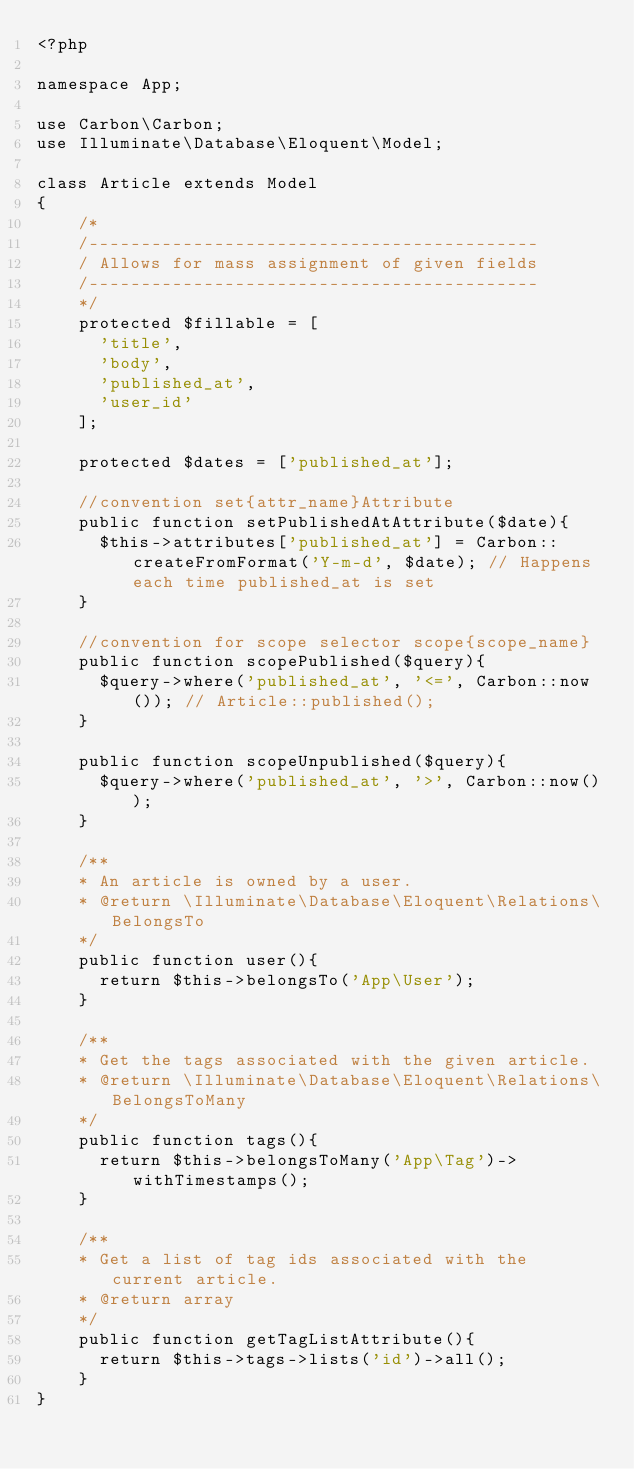<code> <loc_0><loc_0><loc_500><loc_500><_PHP_><?php

namespace App;

use Carbon\Carbon;
use Illuminate\Database\Eloquent\Model;

class Article extends Model
{
    /*
    /-------------------------------------------
    / Allows for mass assignment of given fields
    /-------------------------------------------
    */
    protected $fillable = [
      'title',
      'body',
      'published_at',
      'user_id'
    ];

    protected $dates = ['published_at'];

    //convention set{attr_name}Attribute
    public function setPublishedAtAttribute($date){
      $this->attributes['published_at'] = Carbon::createFromFormat('Y-m-d', $date); // Happens each time published_at is set
    }

    //convention for scope selector scope{scope_name}
    public function scopePublished($query){
      $query->where('published_at', '<=', Carbon::now()); // Article::published();
    }

    public function scopeUnpublished($query){
      $query->where('published_at', '>', Carbon::now());
    }

    /**
    * An article is owned by a user.
    * @return \Illuminate\Database\Eloquent\Relations\BelongsTo
    */
    public function user(){
      return $this->belongsTo('App\User');
    }

    /**
    * Get the tags associated with the given article.
    * @return \Illuminate\Database\Eloquent\Relations\BelongsToMany
    */
    public function tags(){
      return $this->belongsToMany('App\Tag')->withTimestamps();
    }

    /**
    * Get a list of tag ids associated with the current article.
    * @return array
    */
    public function getTagListAttribute(){
      return $this->tags->lists('id')->all();
    }
}
</code> 